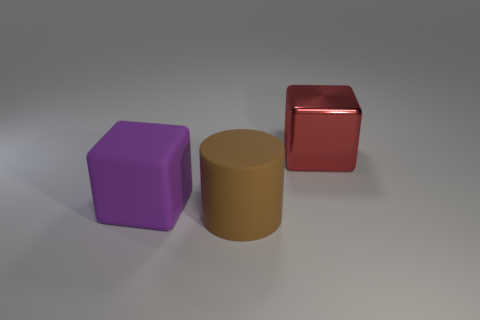Add 2 purple balls. How many objects exist? 5 Subtract 1 cylinders. How many cylinders are left? 0 Add 2 matte objects. How many matte objects exist? 4 Subtract all red cubes. How many cubes are left? 1 Subtract 0 gray balls. How many objects are left? 3 Subtract all cylinders. How many objects are left? 2 Subtract all brown cubes. Subtract all brown cylinders. How many cubes are left? 2 Subtract all brown blocks. How many yellow cylinders are left? 0 Subtract all blue matte balls. Subtract all large purple matte things. How many objects are left? 2 Add 1 matte cylinders. How many matte cylinders are left? 2 